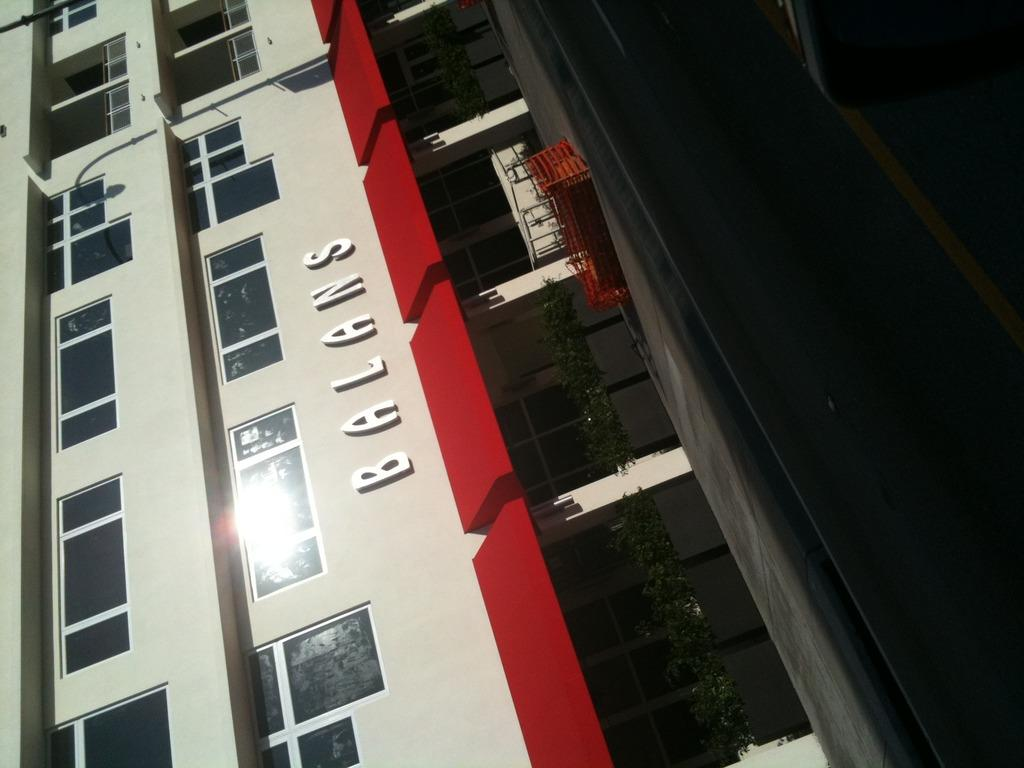What is the main subject of the image? The main subject of the image is a building. What specific features can be observed on the building? The building has windows and text on it. What type of collar can be seen on the building in the image? There is no collar present on the building in the image. What degree of difficulty is the building designed for in the image? The image does not provide information about the building's difficulty level or any degrees related to it. 